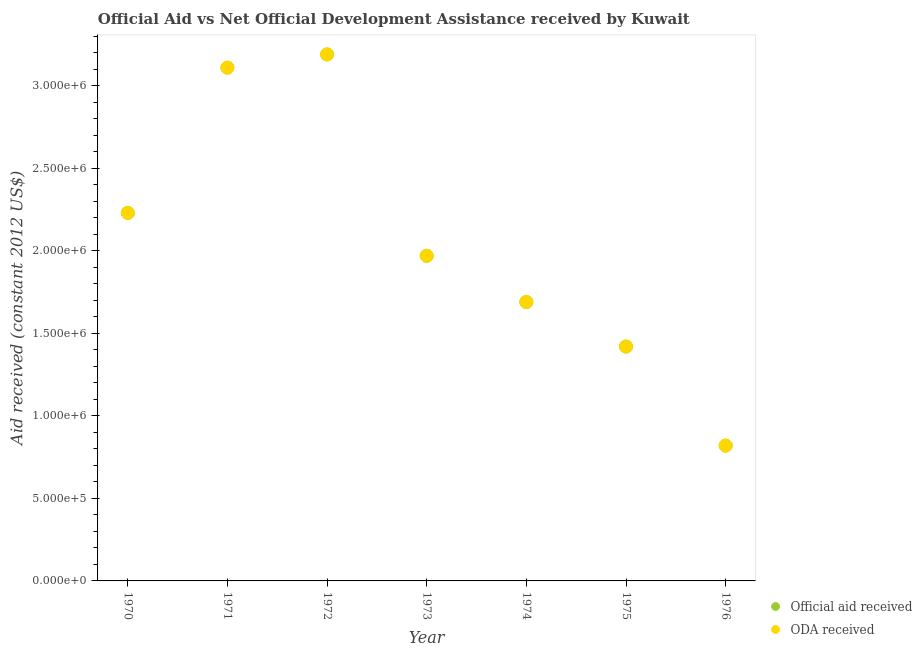Is the number of dotlines equal to the number of legend labels?
Your answer should be compact. Yes. What is the oda received in 1974?
Give a very brief answer. 1.69e+06. Across all years, what is the maximum official aid received?
Offer a terse response. 3.19e+06. Across all years, what is the minimum oda received?
Your answer should be compact. 8.20e+05. In which year was the oda received maximum?
Offer a very short reply. 1972. In which year was the oda received minimum?
Provide a short and direct response. 1976. What is the total oda received in the graph?
Make the answer very short. 1.44e+07. What is the difference between the official aid received in 1971 and that in 1972?
Make the answer very short. -8.00e+04. What is the difference between the official aid received in 1974 and the oda received in 1971?
Provide a short and direct response. -1.42e+06. What is the average oda received per year?
Your response must be concise. 2.06e+06. In the year 1974, what is the difference between the official aid received and oda received?
Give a very brief answer. 0. What is the ratio of the official aid received in 1971 to that in 1975?
Ensure brevity in your answer.  2.19. What is the difference between the highest and the lowest official aid received?
Provide a short and direct response. 2.37e+06. In how many years, is the official aid received greater than the average official aid received taken over all years?
Provide a short and direct response. 3. Is the sum of the oda received in 1970 and 1973 greater than the maximum official aid received across all years?
Keep it short and to the point. Yes. Does the official aid received monotonically increase over the years?
Provide a short and direct response. No. How many dotlines are there?
Ensure brevity in your answer.  2. How many years are there in the graph?
Make the answer very short. 7. Does the graph contain grids?
Keep it short and to the point. No. How many legend labels are there?
Give a very brief answer. 2. What is the title of the graph?
Your answer should be compact. Official Aid vs Net Official Development Assistance received by Kuwait . Does "Canada" appear as one of the legend labels in the graph?
Ensure brevity in your answer.  No. What is the label or title of the X-axis?
Your answer should be compact. Year. What is the label or title of the Y-axis?
Your response must be concise. Aid received (constant 2012 US$). What is the Aid received (constant 2012 US$) in Official aid received in 1970?
Your response must be concise. 2.23e+06. What is the Aid received (constant 2012 US$) of ODA received in 1970?
Your answer should be compact. 2.23e+06. What is the Aid received (constant 2012 US$) of Official aid received in 1971?
Make the answer very short. 3.11e+06. What is the Aid received (constant 2012 US$) of ODA received in 1971?
Provide a succinct answer. 3.11e+06. What is the Aid received (constant 2012 US$) of Official aid received in 1972?
Ensure brevity in your answer.  3.19e+06. What is the Aid received (constant 2012 US$) in ODA received in 1972?
Your answer should be compact. 3.19e+06. What is the Aid received (constant 2012 US$) of Official aid received in 1973?
Offer a terse response. 1.97e+06. What is the Aid received (constant 2012 US$) in ODA received in 1973?
Keep it short and to the point. 1.97e+06. What is the Aid received (constant 2012 US$) of Official aid received in 1974?
Ensure brevity in your answer.  1.69e+06. What is the Aid received (constant 2012 US$) of ODA received in 1974?
Give a very brief answer. 1.69e+06. What is the Aid received (constant 2012 US$) in Official aid received in 1975?
Keep it short and to the point. 1.42e+06. What is the Aid received (constant 2012 US$) of ODA received in 1975?
Provide a short and direct response. 1.42e+06. What is the Aid received (constant 2012 US$) of Official aid received in 1976?
Your answer should be very brief. 8.20e+05. What is the Aid received (constant 2012 US$) of ODA received in 1976?
Ensure brevity in your answer.  8.20e+05. Across all years, what is the maximum Aid received (constant 2012 US$) of Official aid received?
Offer a terse response. 3.19e+06. Across all years, what is the maximum Aid received (constant 2012 US$) of ODA received?
Offer a very short reply. 3.19e+06. Across all years, what is the minimum Aid received (constant 2012 US$) in Official aid received?
Offer a terse response. 8.20e+05. Across all years, what is the minimum Aid received (constant 2012 US$) in ODA received?
Provide a succinct answer. 8.20e+05. What is the total Aid received (constant 2012 US$) in Official aid received in the graph?
Provide a succinct answer. 1.44e+07. What is the total Aid received (constant 2012 US$) of ODA received in the graph?
Offer a terse response. 1.44e+07. What is the difference between the Aid received (constant 2012 US$) of Official aid received in 1970 and that in 1971?
Provide a short and direct response. -8.80e+05. What is the difference between the Aid received (constant 2012 US$) of ODA received in 1970 and that in 1971?
Keep it short and to the point. -8.80e+05. What is the difference between the Aid received (constant 2012 US$) in Official aid received in 1970 and that in 1972?
Offer a terse response. -9.60e+05. What is the difference between the Aid received (constant 2012 US$) in ODA received in 1970 and that in 1972?
Your answer should be very brief. -9.60e+05. What is the difference between the Aid received (constant 2012 US$) of Official aid received in 1970 and that in 1974?
Offer a terse response. 5.40e+05. What is the difference between the Aid received (constant 2012 US$) in ODA received in 1970 and that in 1974?
Give a very brief answer. 5.40e+05. What is the difference between the Aid received (constant 2012 US$) in Official aid received in 1970 and that in 1975?
Offer a very short reply. 8.10e+05. What is the difference between the Aid received (constant 2012 US$) in ODA received in 1970 and that in 1975?
Your answer should be very brief. 8.10e+05. What is the difference between the Aid received (constant 2012 US$) in Official aid received in 1970 and that in 1976?
Make the answer very short. 1.41e+06. What is the difference between the Aid received (constant 2012 US$) of ODA received in 1970 and that in 1976?
Provide a succinct answer. 1.41e+06. What is the difference between the Aid received (constant 2012 US$) of Official aid received in 1971 and that in 1972?
Your response must be concise. -8.00e+04. What is the difference between the Aid received (constant 2012 US$) in Official aid received in 1971 and that in 1973?
Offer a very short reply. 1.14e+06. What is the difference between the Aid received (constant 2012 US$) of ODA received in 1971 and that in 1973?
Keep it short and to the point. 1.14e+06. What is the difference between the Aid received (constant 2012 US$) in Official aid received in 1971 and that in 1974?
Give a very brief answer. 1.42e+06. What is the difference between the Aid received (constant 2012 US$) in ODA received in 1971 and that in 1974?
Provide a short and direct response. 1.42e+06. What is the difference between the Aid received (constant 2012 US$) in Official aid received in 1971 and that in 1975?
Make the answer very short. 1.69e+06. What is the difference between the Aid received (constant 2012 US$) of ODA received in 1971 and that in 1975?
Make the answer very short. 1.69e+06. What is the difference between the Aid received (constant 2012 US$) of Official aid received in 1971 and that in 1976?
Your response must be concise. 2.29e+06. What is the difference between the Aid received (constant 2012 US$) of ODA received in 1971 and that in 1976?
Offer a very short reply. 2.29e+06. What is the difference between the Aid received (constant 2012 US$) in Official aid received in 1972 and that in 1973?
Offer a terse response. 1.22e+06. What is the difference between the Aid received (constant 2012 US$) in ODA received in 1972 and that in 1973?
Ensure brevity in your answer.  1.22e+06. What is the difference between the Aid received (constant 2012 US$) in Official aid received in 1972 and that in 1974?
Your answer should be compact. 1.50e+06. What is the difference between the Aid received (constant 2012 US$) in ODA received in 1972 and that in 1974?
Give a very brief answer. 1.50e+06. What is the difference between the Aid received (constant 2012 US$) in Official aid received in 1972 and that in 1975?
Provide a succinct answer. 1.77e+06. What is the difference between the Aid received (constant 2012 US$) in ODA received in 1972 and that in 1975?
Offer a terse response. 1.77e+06. What is the difference between the Aid received (constant 2012 US$) in Official aid received in 1972 and that in 1976?
Offer a very short reply. 2.37e+06. What is the difference between the Aid received (constant 2012 US$) of ODA received in 1972 and that in 1976?
Offer a terse response. 2.37e+06. What is the difference between the Aid received (constant 2012 US$) of Official aid received in 1973 and that in 1975?
Provide a succinct answer. 5.50e+05. What is the difference between the Aid received (constant 2012 US$) of ODA received in 1973 and that in 1975?
Offer a very short reply. 5.50e+05. What is the difference between the Aid received (constant 2012 US$) in Official aid received in 1973 and that in 1976?
Give a very brief answer. 1.15e+06. What is the difference between the Aid received (constant 2012 US$) of ODA received in 1973 and that in 1976?
Keep it short and to the point. 1.15e+06. What is the difference between the Aid received (constant 2012 US$) in Official aid received in 1974 and that in 1975?
Your response must be concise. 2.70e+05. What is the difference between the Aid received (constant 2012 US$) of Official aid received in 1974 and that in 1976?
Your answer should be compact. 8.70e+05. What is the difference between the Aid received (constant 2012 US$) of ODA received in 1974 and that in 1976?
Offer a terse response. 8.70e+05. What is the difference between the Aid received (constant 2012 US$) of Official aid received in 1970 and the Aid received (constant 2012 US$) of ODA received in 1971?
Offer a terse response. -8.80e+05. What is the difference between the Aid received (constant 2012 US$) in Official aid received in 1970 and the Aid received (constant 2012 US$) in ODA received in 1972?
Make the answer very short. -9.60e+05. What is the difference between the Aid received (constant 2012 US$) in Official aid received in 1970 and the Aid received (constant 2012 US$) in ODA received in 1974?
Offer a terse response. 5.40e+05. What is the difference between the Aid received (constant 2012 US$) in Official aid received in 1970 and the Aid received (constant 2012 US$) in ODA received in 1975?
Ensure brevity in your answer.  8.10e+05. What is the difference between the Aid received (constant 2012 US$) of Official aid received in 1970 and the Aid received (constant 2012 US$) of ODA received in 1976?
Offer a terse response. 1.41e+06. What is the difference between the Aid received (constant 2012 US$) of Official aid received in 1971 and the Aid received (constant 2012 US$) of ODA received in 1973?
Provide a short and direct response. 1.14e+06. What is the difference between the Aid received (constant 2012 US$) in Official aid received in 1971 and the Aid received (constant 2012 US$) in ODA received in 1974?
Provide a succinct answer. 1.42e+06. What is the difference between the Aid received (constant 2012 US$) of Official aid received in 1971 and the Aid received (constant 2012 US$) of ODA received in 1975?
Make the answer very short. 1.69e+06. What is the difference between the Aid received (constant 2012 US$) in Official aid received in 1971 and the Aid received (constant 2012 US$) in ODA received in 1976?
Offer a very short reply. 2.29e+06. What is the difference between the Aid received (constant 2012 US$) of Official aid received in 1972 and the Aid received (constant 2012 US$) of ODA received in 1973?
Give a very brief answer. 1.22e+06. What is the difference between the Aid received (constant 2012 US$) of Official aid received in 1972 and the Aid received (constant 2012 US$) of ODA received in 1974?
Give a very brief answer. 1.50e+06. What is the difference between the Aid received (constant 2012 US$) in Official aid received in 1972 and the Aid received (constant 2012 US$) in ODA received in 1975?
Provide a short and direct response. 1.77e+06. What is the difference between the Aid received (constant 2012 US$) of Official aid received in 1972 and the Aid received (constant 2012 US$) of ODA received in 1976?
Your answer should be compact. 2.37e+06. What is the difference between the Aid received (constant 2012 US$) of Official aid received in 1973 and the Aid received (constant 2012 US$) of ODA received in 1974?
Make the answer very short. 2.80e+05. What is the difference between the Aid received (constant 2012 US$) of Official aid received in 1973 and the Aid received (constant 2012 US$) of ODA received in 1976?
Offer a terse response. 1.15e+06. What is the difference between the Aid received (constant 2012 US$) of Official aid received in 1974 and the Aid received (constant 2012 US$) of ODA received in 1975?
Offer a very short reply. 2.70e+05. What is the difference between the Aid received (constant 2012 US$) in Official aid received in 1974 and the Aid received (constant 2012 US$) in ODA received in 1976?
Offer a very short reply. 8.70e+05. What is the difference between the Aid received (constant 2012 US$) of Official aid received in 1975 and the Aid received (constant 2012 US$) of ODA received in 1976?
Keep it short and to the point. 6.00e+05. What is the average Aid received (constant 2012 US$) in Official aid received per year?
Give a very brief answer. 2.06e+06. What is the average Aid received (constant 2012 US$) of ODA received per year?
Your answer should be compact. 2.06e+06. In the year 1970, what is the difference between the Aid received (constant 2012 US$) of Official aid received and Aid received (constant 2012 US$) of ODA received?
Offer a very short reply. 0. In the year 1971, what is the difference between the Aid received (constant 2012 US$) of Official aid received and Aid received (constant 2012 US$) of ODA received?
Your answer should be very brief. 0. In the year 1974, what is the difference between the Aid received (constant 2012 US$) of Official aid received and Aid received (constant 2012 US$) of ODA received?
Keep it short and to the point. 0. In the year 1975, what is the difference between the Aid received (constant 2012 US$) of Official aid received and Aid received (constant 2012 US$) of ODA received?
Offer a terse response. 0. What is the ratio of the Aid received (constant 2012 US$) in Official aid received in 1970 to that in 1971?
Give a very brief answer. 0.72. What is the ratio of the Aid received (constant 2012 US$) of ODA received in 1970 to that in 1971?
Offer a terse response. 0.72. What is the ratio of the Aid received (constant 2012 US$) in Official aid received in 1970 to that in 1972?
Offer a terse response. 0.7. What is the ratio of the Aid received (constant 2012 US$) in ODA received in 1970 to that in 1972?
Offer a very short reply. 0.7. What is the ratio of the Aid received (constant 2012 US$) in Official aid received in 1970 to that in 1973?
Ensure brevity in your answer.  1.13. What is the ratio of the Aid received (constant 2012 US$) in ODA received in 1970 to that in 1973?
Ensure brevity in your answer.  1.13. What is the ratio of the Aid received (constant 2012 US$) in Official aid received in 1970 to that in 1974?
Offer a terse response. 1.32. What is the ratio of the Aid received (constant 2012 US$) in ODA received in 1970 to that in 1974?
Provide a short and direct response. 1.32. What is the ratio of the Aid received (constant 2012 US$) in Official aid received in 1970 to that in 1975?
Ensure brevity in your answer.  1.57. What is the ratio of the Aid received (constant 2012 US$) in ODA received in 1970 to that in 1975?
Provide a short and direct response. 1.57. What is the ratio of the Aid received (constant 2012 US$) in Official aid received in 1970 to that in 1976?
Provide a succinct answer. 2.72. What is the ratio of the Aid received (constant 2012 US$) in ODA received in 1970 to that in 1976?
Your answer should be very brief. 2.72. What is the ratio of the Aid received (constant 2012 US$) of Official aid received in 1971 to that in 1972?
Provide a succinct answer. 0.97. What is the ratio of the Aid received (constant 2012 US$) of ODA received in 1971 to that in 1972?
Offer a very short reply. 0.97. What is the ratio of the Aid received (constant 2012 US$) of Official aid received in 1971 to that in 1973?
Ensure brevity in your answer.  1.58. What is the ratio of the Aid received (constant 2012 US$) in ODA received in 1971 to that in 1973?
Your response must be concise. 1.58. What is the ratio of the Aid received (constant 2012 US$) of Official aid received in 1971 to that in 1974?
Your response must be concise. 1.84. What is the ratio of the Aid received (constant 2012 US$) in ODA received in 1971 to that in 1974?
Keep it short and to the point. 1.84. What is the ratio of the Aid received (constant 2012 US$) of Official aid received in 1971 to that in 1975?
Provide a short and direct response. 2.19. What is the ratio of the Aid received (constant 2012 US$) in ODA received in 1971 to that in 1975?
Give a very brief answer. 2.19. What is the ratio of the Aid received (constant 2012 US$) of Official aid received in 1971 to that in 1976?
Your response must be concise. 3.79. What is the ratio of the Aid received (constant 2012 US$) of ODA received in 1971 to that in 1976?
Provide a succinct answer. 3.79. What is the ratio of the Aid received (constant 2012 US$) in Official aid received in 1972 to that in 1973?
Your answer should be compact. 1.62. What is the ratio of the Aid received (constant 2012 US$) of ODA received in 1972 to that in 1973?
Offer a very short reply. 1.62. What is the ratio of the Aid received (constant 2012 US$) of Official aid received in 1972 to that in 1974?
Give a very brief answer. 1.89. What is the ratio of the Aid received (constant 2012 US$) in ODA received in 1972 to that in 1974?
Keep it short and to the point. 1.89. What is the ratio of the Aid received (constant 2012 US$) of Official aid received in 1972 to that in 1975?
Keep it short and to the point. 2.25. What is the ratio of the Aid received (constant 2012 US$) in ODA received in 1972 to that in 1975?
Offer a very short reply. 2.25. What is the ratio of the Aid received (constant 2012 US$) in Official aid received in 1972 to that in 1976?
Provide a succinct answer. 3.89. What is the ratio of the Aid received (constant 2012 US$) of ODA received in 1972 to that in 1976?
Offer a very short reply. 3.89. What is the ratio of the Aid received (constant 2012 US$) of Official aid received in 1973 to that in 1974?
Make the answer very short. 1.17. What is the ratio of the Aid received (constant 2012 US$) of ODA received in 1973 to that in 1974?
Your answer should be compact. 1.17. What is the ratio of the Aid received (constant 2012 US$) in Official aid received in 1973 to that in 1975?
Provide a succinct answer. 1.39. What is the ratio of the Aid received (constant 2012 US$) of ODA received in 1973 to that in 1975?
Offer a terse response. 1.39. What is the ratio of the Aid received (constant 2012 US$) of Official aid received in 1973 to that in 1976?
Your response must be concise. 2.4. What is the ratio of the Aid received (constant 2012 US$) of ODA received in 1973 to that in 1976?
Offer a terse response. 2.4. What is the ratio of the Aid received (constant 2012 US$) of Official aid received in 1974 to that in 1975?
Offer a very short reply. 1.19. What is the ratio of the Aid received (constant 2012 US$) of ODA received in 1974 to that in 1975?
Make the answer very short. 1.19. What is the ratio of the Aid received (constant 2012 US$) of Official aid received in 1974 to that in 1976?
Your response must be concise. 2.06. What is the ratio of the Aid received (constant 2012 US$) of ODA received in 1974 to that in 1976?
Your answer should be very brief. 2.06. What is the ratio of the Aid received (constant 2012 US$) in Official aid received in 1975 to that in 1976?
Offer a terse response. 1.73. What is the ratio of the Aid received (constant 2012 US$) in ODA received in 1975 to that in 1976?
Keep it short and to the point. 1.73. What is the difference between the highest and the second highest Aid received (constant 2012 US$) of ODA received?
Make the answer very short. 8.00e+04. What is the difference between the highest and the lowest Aid received (constant 2012 US$) of Official aid received?
Your answer should be very brief. 2.37e+06. What is the difference between the highest and the lowest Aid received (constant 2012 US$) of ODA received?
Provide a short and direct response. 2.37e+06. 